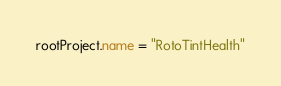Convert code to text. <code><loc_0><loc_0><loc_500><loc_500><_Kotlin_>rootProject.name = "RotoTintHealth"
</code> 